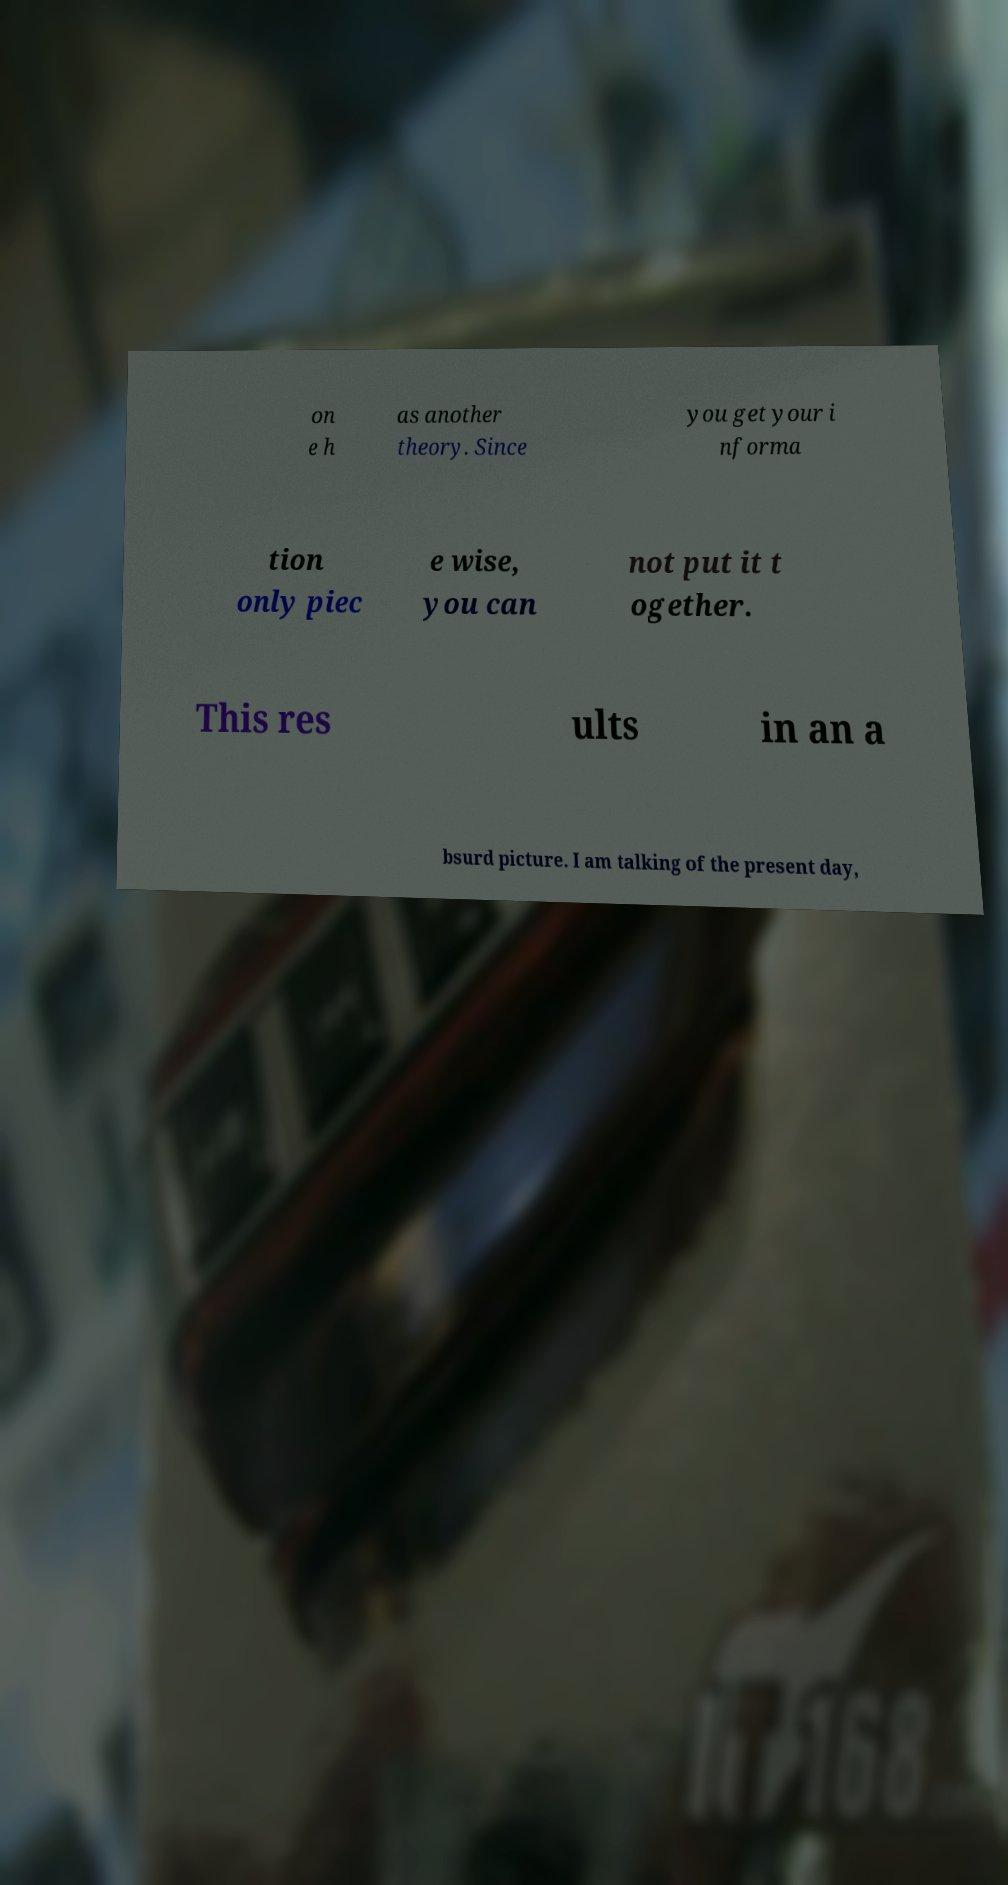There's text embedded in this image that I need extracted. Can you transcribe it verbatim? on e h as another theory. Since you get your i nforma tion only piec e wise, you can not put it t ogether. This res ults in an a bsurd picture. I am talking of the present day, 